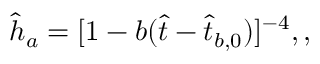<formula> <loc_0><loc_0><loc_500><loc_500>\hat { h } _ { a } = [ 1 - b ( \hat { t } - \hat { t } _ { b , 0 } ) ] ^ { - 4 } , ,</formula> 